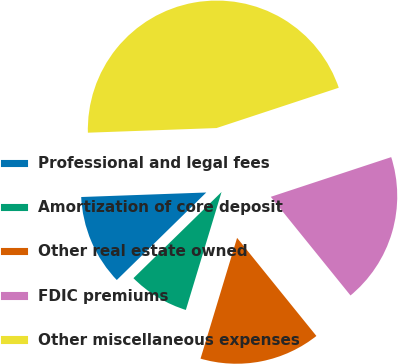Convert chart to OTSL. <chart><loc_0><loc_0><loc_500><loc_500><pie_chart><fcel>Professional and legal fees<fcel>Amortization of core deposit<fcel>Other real estate owned<fcel>FDIC premiums<fcel>Other miscellaneous expenses<nl><fcel>11.75%<fcel>8.0%<fcel>15.5%<fcel>19.25%<fcel>45.51%<nl></chart> 